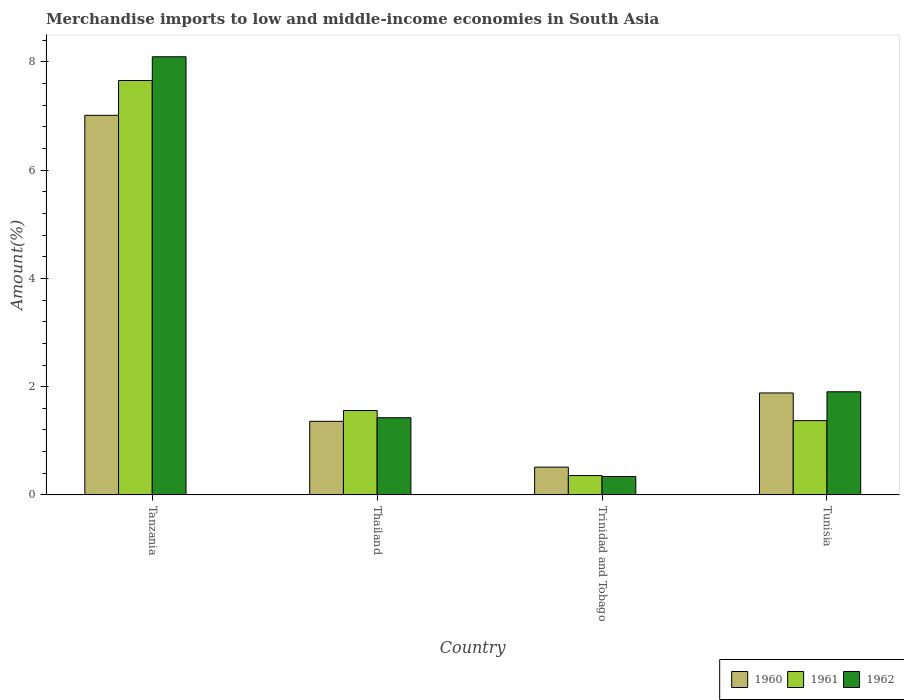How many different coloured bars are there?
Provide a short and direct response. 3. Are the number of bars per tick equal to the number of legend labels?
Keep it short and to the point. Yes. Are the number of bars on each tick of the X-axis equal?
Your response must be concise. Yes. How many bars are there on the 3rd tick from the left?
Keep it short and to the point. 3. What is the label of the 4th group of bars from the left?
Make the answer very short. Tunisia. In how many cases, is the number of bars for a given country not equal to the number of legend labels?
Provide a succinct answer. 0. What is the percentage of amount earned from merchandise imports in 1961 in Tanzania?
Keep it short and to the point. 7.66. Across all countries, what is the maximum percentage of amount earned from merchandise imports in 1961?
Your answer should be very brief. 7.66. Across all countries, what is the minimum percentage of amount earned from merchandise imports in 1960?
Ensure brevity in your answer.  0.51. In which country was the percentage of amount earned from merchandise imports in 1962 maximum?
Make the answer very short. Tanzania. In which country was the percentage of amount earned from merchandise imports in 1961 minimum?
Offer a very short reply. Trinidad and Tobago. What is the total percentage of amount earned from merchandise imports in 1962 in the graph?
Ensure brevity in your answer.  11.77. What is the difference between the percentage of amount earned from merchandise imports in 1961 in Thailand and that in Trinidad and Tobago?
Provide a succinct answer. 1.2. What is the difference between the percentage of amount earned from merchandise imports in 1960 in Trinidad and Tobago and the percentage of amount earned from merchandise imports in 1961 in Thailand?
Provide a succinct answer. -1.05. What is the average percentage of amount earned from merchandise imports in 1962 per country?
Provide a succinct answer. 2.94. What is the difference between the percentage of amount earned from merchandise imports of/in 1960 and percentage of amount earned from merchandise imports of/in 1961 in Thailand?
Provide a succinct answer. -0.2. In how many countries, is the percentage of amount earned from merchandise imports in 1961 greater than 7.6 %?
Your answer should be very brief. 1. What is the ratio of the percentage of amount earned from merchandise imports in 1962 in Tanzania to that in Trinidad and Tobago?
Your answer should be very brief. 23.83. What is the difference between the highest and the second highest percentage of amount earned from merchandise imports in 1962?
Ensure brevity in your answer.  6.19. What is the difference between the highest and the lowest percentage of amount earned from merchandise imports in 1960?
Offer a terse response. 6.5. Is the sum of the percentage of amount earned from merchandise imports in 1961 in Tanzania and Thailand greater than the maximum percentage of amount earned from merchandise imports in 1960 across all countries?
Provide a short and direct response. Yes. How many bars are there?
Your answer should be very brief. 12. How many countries are there in the graph?
Ensure brevity in your answer.  4. Does the graph contain grids?
Give a very brief answer. No. Where does the legend appear in the graph?
Make the answer very short. Bottom right. What is the title of the graph?
Provide a short and direct response. Merchandise imports to low and middle-income economies in South Asia. Does "1979" appear as one of the legend labels in the graph?
Your answer should be very brief. No. What is the label or title of the X-axis?
Your answer should be very brief. Country. What is the label or title of the Y-axis?
Your answer should be very brief. Amount(%). What is the Amount(%) in 1960 in Tanzania?
Offer a terse response. 7.01. What is the Amount(%) in 1961 in Tanzania?
Offer a terse response. 7.66. What is the Amount(%) in 1962 in Tanzania?
Offer a very short reply. 8.1. What is the Amount(%) in 1960 in Thailand?
Your answer should be very brief. 1.36. What is the Amount(%) of 1961 in Thailand?
Your response must be concise. 1.56. What is the Amount(%) of 1962 in Thailand?
Your response must be concise. 1.43. What is the Amount(%) of 1960 in Trinidad and Tobago?
Keep it short and to the point. 0.51. What is the Amount(%) of 1961 in Trinidad and Tobago?
Ensure brevity in your answer.  0.36. What is the Amount(%) in 1962 in Trinidad and Tobago?
Offer a very short reply. 0.34. What is the Amount(%) of 1960 in Tunisia?
Provide a short and direct response. 1.88. What is the Amount(%) in 1961 in Tunisia?
Make the answer very short. 1.37. What is the Amount(%) of 1962 in Tunisia?
Make the answer very short. 1.91. Across all countries, what is the maximum Amount(%) of 1960?
Your answer should be compact. 7.01. Across all countries, what is the maximum Amount(%) of 1961?
Give a very brief answer. 7.66. Across all countries, what is the maximum Amount(%) in 1962?
Your response must be concise. 8.1. Across all countries, what is the minimum Amount(%) of 1960?
Ensure brevity in your answer.  0.51. Across all countries, what is the minimum Amount(%) of 1961?
Your answer should be compact. 0.36. Across all countries, what is the minimum Amount(%) in 1962?
Offer a terse response. 0.34. What is the total Amount(%) of 1960 in the graph?
Keep it short and to the point. 10.77. What is the total Amount(%) in 1961 in the graph?
Offer a terse response. 10.94. What is the total Amount(%) of 1962 in the graph?
Your answer should be compact. 11.77. What is the difference between the Amount(%) of 1960 in Tanzania and that in Thailand?
Provide a succinct answer. 5.65. What is the difference between the Amount(%) in 1961 in Tanzania and that in Thailand?
Make the answer very short. 6.1. What is the difference between the Amount(%) of 1962 in Tanzania and that in Thailand?
Ensure brevity in your answer.  6.67. What is the difference between the Amount(%) in 1960 in Tanzania and that in Trinidad and Tobago?
Your answer should be compact. 6.5. What is the difference between the Amount(%) in 1961 in Tanzania and that in Trinidad and Tobago?
Ensure brevity in your answer.  7.3. What is the difference between the Amount(%) of 1962 in Tanzania and that in Trinidad and Tobago?
Make the answer very short. 7.76. What is the difference between the Amount(%) of 1960 in Tanzania and that in Tunisia?
Keep it short and to the point. 5.13. What is the difference between the Amount(%) of 1961 in Tanzania and that in Tunisia?
Your answer should be very brief. 6.28. What is the difference between the Amount(%) of 1962 in Tanzania and that in Tunisia?
Your answer should be very brief. 6.19. What is the difference between the Amount(%) of 1960 in Thailand and that in Trinidad and Tobago?
Provide a short and direct response. 0.85. What is the difference between the Amount(%) in 1961 in Thailand and that in Trinidad and Tobago?
Your answer should be compact. 1.2. What is the difference between the Amount(%) in 1962 in Thailand and that in Trinidad and Tobago?
Your response must be concise. 1.09. What is the difference between the Amount(%) of 1960 in Thailand and that in Tunisia?
Provide a short and direct response. -0.52. What is the difference between the Amount(%) in 1961 in Thailand and that in Tunisia?
Offer a terse response. 0.19. What is the difference between the Amount(%) of 1962 in Thailand and that in Tunisia?
Provide a succinct answer. -0.48. What is the difference between the Amount(%) in 1960 in Trinidad and Tobago and that in Tunisia?
Give a very brief answer. -1.37. What is the difference between the Amount(%) of 1961 in Trinidad and Tobago and that in Tunisia?
Your response must be concise. -1.01. What is the difference between the Amount(%) in 1962 in Trinidad and Tobago and that in Tunisia?
Ensure brevity in your answer.  -1.57. What is the difference between the Amount(%) of 1960 in Tanzania and the Amount(%) of 1961 in Thailand?
Your response must be concise. 5.45. What is the difference between the Amount(%) of 1960 in Tanzania and the Amount(%) of 1962 in Thailand?
Provide a succinct answer. 5.59. What is the difference between the Amount(%) of 1961 in Tanzania and the Amount(%) of 1962 in Thailand?
Your response must be concise. 6.23. What is the difference between the Amount(%) in 1960 in Tanzania and the Amount(%) in 1961 in Trinidad and Tobago?
Provide a succinct answer. 6.66. What is the difference between the Amount(%) in 1960 in Tanzania and the Amount(%) in 1962 in Trinidad and Tobago?
Offer a terse response. 6.67. What is the difference between the Amount(%) of 1961 in Tanzania and the Amount(%) of 1962 in Trinidad and Tobago?
Provide a short and direct response. 7.32. What is the difference between the Amount(%) in 1960 in Tanzania and the Amount(%) in 1961 in Tunisia?
Make the answer very short. 5.64. What is the difference between the Amount(%) in 1960 in Tanzania and the Amount(%) in 1962 in Tunisia?
Your answer should be very brief. 5.11. What is the difference between the Amount(%) in 1961 in Tanzania and the Amount(%) in 1962 in Tunisia?
Provide a succinct answer. 5.75. What is the difference between the Amount(%) in 1960 in Thailand and the Amount(%) in 1961 in Trinidad and Tobago?
Provide a succinct answer. 1. What is the difference between the Amount(%) of 1960 in Thailand and the Amount(%) of 1962 in Trinidad and Tobago?
Your answer should be compact. 1.02. What is the difference between the Amount(%) in 1961 in Thailand and the Amount(%) in 1962 in Trinidad and Tobago?
Ensure brevity in your answer.  1.22. What is the difference between the Amount(%) in 1960 in Thailand and the Amount(%) in 1961 in Tunisia?
Give a very brief answer. -0.01. What is the difference between the Amount(%) in 1960 in Thailand and the Amount(%) in 1962 in Tunisia?
Ensure brevity in your answer.  -0.55. What is the difference between the Amount(%) in 1961 in Thailand and the Amount(%) in 1962 in Tunisia?
Offer a very short reply. -0.35. What is the difference between the Amount(%) of 1960 in Trinidad and Tobago and the Amount(%) of 1961 in Tunisia?
Your answer should be compact. -0.86. What is the difference between the Amount(%) in 1960 in Trinidad and Tobago and the Amount(%) in 1962 in Tunisia?
Ensure brevity in your answer.  -1.39. What is the difference between the Amount(%) in 1961 in Trinidad and Tobago and the Amount(%) in 1962 in Tunisia?
Keep it short and to the point. -1.55. What is the average Amount(%) of 1960 per country?
Make the answer very short. 2.69. What is the average Amount(%) of 1961 per country?
Keep it short and to the point. 2.74. What is the average Amount(%) of 1962 per country?
Your answer should be compact. 2.94. What is the difference between the Amount(%) of 1960 and Amount(%) of 1961 in Tanzania?
Give a very brief answer. -0.64. What is the difference between the Amount(%) in 1960 and Amount(%) in 1962 in Tanzania?
Provide a short and direct response. -1.08. What is the difference between the Amount(%) of 1961 and Amount(%) of 1962 in Tanzania?
Offer a terse response. -0.44. What is the difference between the Amount(%) of 1960 and Amount(%) of 1961 in Thailand?
Ensure brevity in your answer.  -0.2. What is the difference between the Amount(%) in 1960 and Amount(%) in 1962 in Thailand?
Ensure brevity in your answer.  -0.07. What is the difference between the Amount(%) of 1961 and Amount(%) of 1962 in Thailand?
Provide a short and direct response. 0.13. What is the difference between the Amount(%) in 1960 and Amount(%) in 1961 in Trinidad and Tobago?
Offer a very short reply. 0.16. What is the difference between the Amount(%) of 1960 and Amount(%) of 1962 in Trinidad and Tobago?
Your response must be concise. 0.17. What is the difference between the Amount(%) of 1961 and Amount(%) of 1962 in Trinidad and Tobago?
Your answer should be compact. 0.02. What is the difference between the Amount(%) of 1960 and Amount(%) of 1961 in Tunisia?
Keep it short and to the point. 0.51. What is the difference between the Amount(%) in 1960 and Amount(%) in 1962 in Tunisia?
Provide a succinct answer. -0.02. What is the difference between the Amount(%) of 1961 and Amount(%) of 1962 in Tunisia?
Ensure brevity in your answer.  -0.53. What is the ratio of the Amount(%) of 1960 in Tanzania to that in Thailand?
Ensure brevity in your answer.  5.16. What is the ratio of the Amount(%) of 1961 in Tanzania to that in Thailand?
Provide a short and direct response. 4.91. What is the ratio of the Amount(%) in 1962 in Tanzania to that in Thailand?
Your answer should be compact. 5.68. What is the ratio of the Amount(%) in 1960 in Tanzania to that in Trinidad and Tobago?
Offer a terse response. 13.67. What is the ratio of the Amount(%) of 1961 in Tanzania to that in Trinidad and Tobago?
Provide a succinct answer. 21.42. What is the ratio of the Amount(%) in 1962 in Tanzania to that in Trinidad and Tobago?
Give a very brief answer. 23.83. What is the ratio of the Amount(%) in 1960 in Tanzania to that in Tunisia?
Provide a succinct answer. 3.72. What is the ratio of the Amount(%) in 1961 in Tanzania to that in Tunisia?
Provide a short and direct response. 5.58. What is the ratio of the Amount(%) in 1962 in Tanzania to that in Tunisia?
Your answer should be compact. 4.25. What is the ratio of the Amount(%) in 1960 in Thailand to that in Trinidad and Tobago?
Your answer should be very brief. 2.65. What is the ratio of the Amount(%) of 1961 in Thailand to that in Trinidad and Tobago?
Offer a very short reply. 4.36. What is the ratio of the Amount(%) of 1962 in Thailand to that in Trinidad and Tobago?
Ensure brevity in your answer.  4.2. What is the ratio of the Amount(%) of 1960 in Thailand to that in Tunisia?
Your response must be concise. 0.72. What is the ratio of the Amount(%) of 1961 in Thailand to that in Tunisia?
Ensure brevity in your answer.  1.14. What is the ratio of the Amount(%) of 1962 in Thailand to that in Tunisia?
Make the answer very short. 0.75. What is the ratio of the Amount(%) of 1960 in Trinidad and Tobago to that in Tunisia?
Provide a succinct answer. 0.27. What is the ratio of the Amount(%) of 1961 in Trinidad and Tobago to that in Tunisia?
Your answer should be compact. 0.26. What is the ratio of the Amount(%) in 1962 in Trinidad and Tobago to that in Tunisia?
Offer a very short reply. 0.18. What is the difference between the highest and the second highest Amount(%) in 1960?
Your answer should be compact. 5.13. What is the difference between the highest and the second highest Amount(%) of 1961?
Keep it short and to the point. 6.1. What is the difference between the highest and the second highest Amount(%) of 1962?
Offer a very short reply. 6.19. What is the difference between the highest and the lowest Amount(%) of 1960?
Give a very brief answer. 6.5. What is the difference between the highest and the lowest Amount(%) of 1961?
Provide a succinct answer. 7.3. What is the difference between the highest and the lowest Amount(%) of 1962?
Make the answer very short. 7.76. 